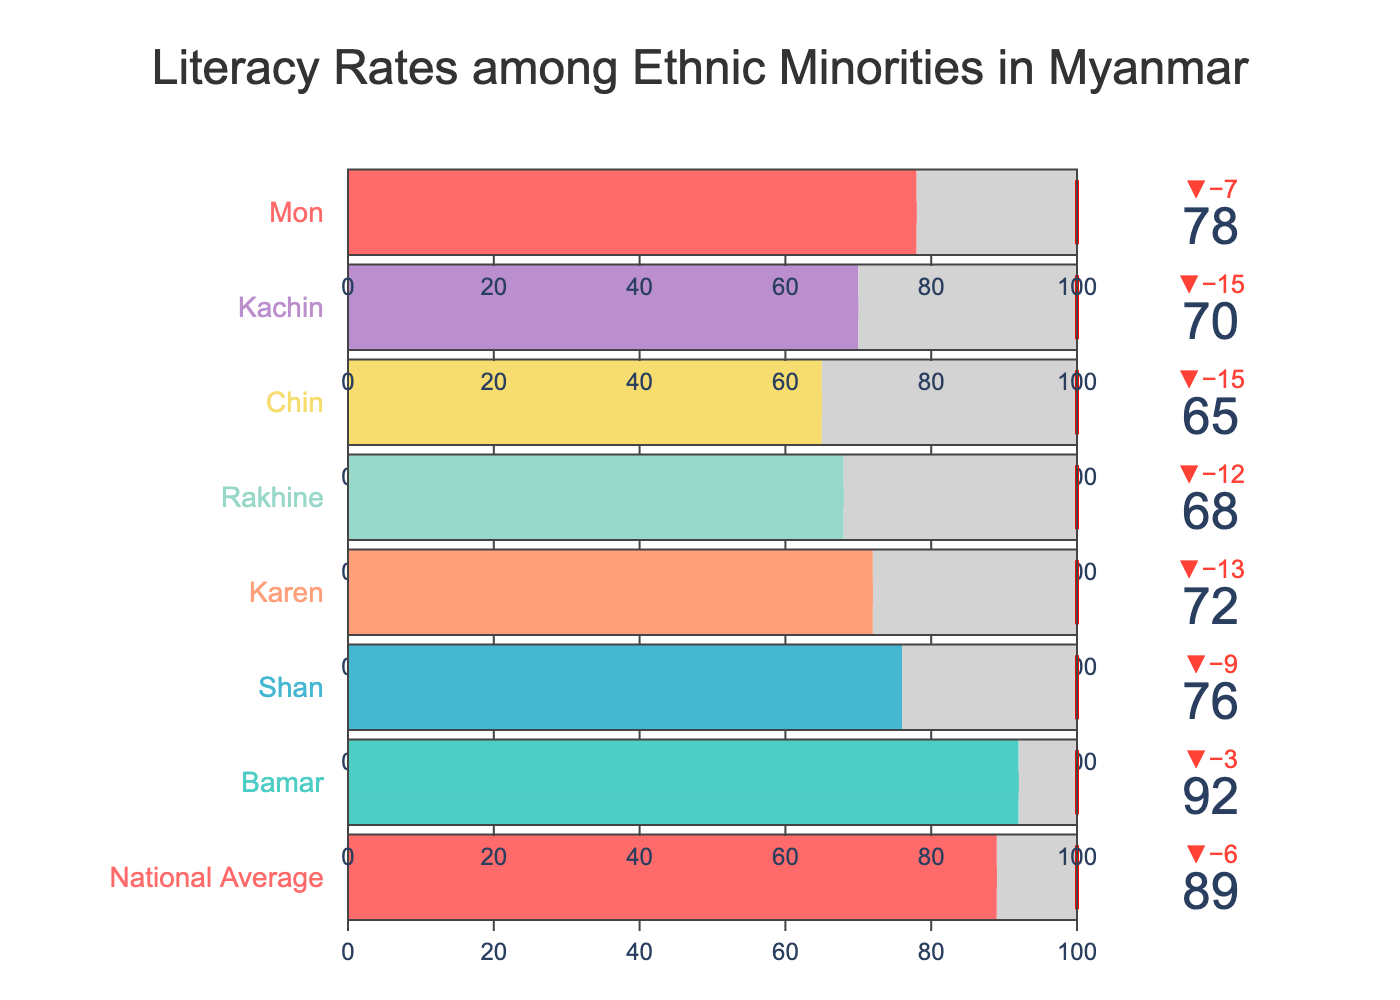Which ethnic group has the highest literacy rate? The highest bar in the figure represents the group with the highest literacy rate. The Bamar group has the bar reaching 92, which is the highest.
Answer: Bamar What is the national average literacy rate? Look for the bar labeled "National Average." The bar represents the literacy rate value as 89.
Answer: 89 By how much does the Rakhine literacy rate fall short of its target? The figure shows Rakhine's actual literacy rate as 68 and its target as 80. Subtract the actual rate from the target: 80 - 68 = 12.
Answer: 12 Which ethnic group's literacy rate is closest to its target? Compare the deltas (differences) between the actual and target for each group. The Bamar group has a delta of 3, which is the smallest difference.
Answer: Bamar How much higher is the UNESCO benchmark than the highest actual literacy rate? The UNESCO benchmark is 100. The highest actual literacy rate is 92 (Bamar). Subtract 92 from 100: 100 - 92 = 8.
Answer: 8 What is the average actual literacy rate of the minority groups shown? Calculate the average of the actual literacy rates of the six minority groups: (76 + 72 + 68 + 65 + 70 + 78)/6. This equals (429 / 6) = 71.5.
Answer: 71.5 Which ethnic groups have an actual literacy rate below the national average? Check the ethnic groups where the actual literacy rate is less than 89 (National Average). These groups are Shan (76), Karen (72), Rakhine (68), Chin (65), Kachin (70), and Mon (78).
Answer: Shan, Karen, Rakhine, Chin, Kachin, Mon By how much does the actual literacy rate of the Chin group differ from the national average? The actual literacy rate of the Chin group is 65, and the national average is 89. Subtract the Chin rate from the national average: 89 - 65 = 24.
Answer: 24 Which group has made the least progress towards the UNESCO benchmark? Compare the gaps between the UNESCO benchmark of 100 and the actual literacy rates. The Chin group, with an actual rate of 65, is the lowest. So, the gap is 100 - 65 = 35.
Answer: Chin 